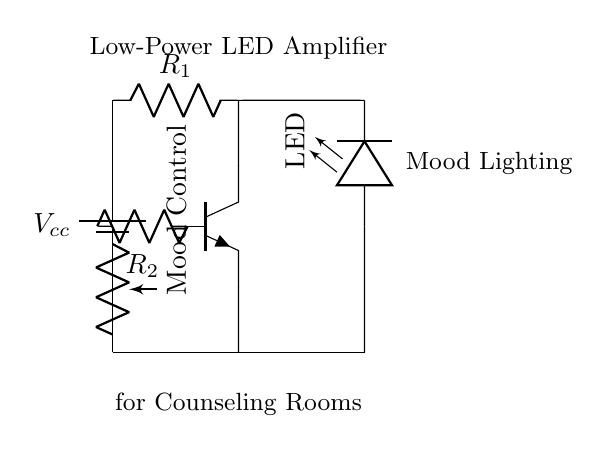What type of transistor is used in this circuit? The circuit diagram labels the transistor as npn, indicating it is an NPN type transistor. This can be confirmed by the specific labeling shown next to the drawn component.
Answer: NPN What is the purpose of the potentiometer in the circuit? The potentiometer, labeled as "Mood Control," adjusts the current flowing through the circuit, allowing the brightness of the LED to be changed for mood lighting. This function is essential in tailoring the lighting to fit different counseling environments.
Answer: Mood Control How many resistors are shown in the circuit? There are two resistors indicated in the circuit diagram, labeled as R1 and R2. This can be easily counted by identifying the resistor symbols within the circuit.
Answer: Two What component provides the power supply for the circuit? The power supply component in the circuit is labeled as Vcc, which signifies it is a battery that supplies voltage to the rest of the circuit. This is clearly marked at the beginning of the circuit.
Answer: Battery What does the LED represent in this configuration? The LED component in the circuit represents the light source used for mood lighting, indicated by the label next to the LED symbol. It visually demonstrates where the light emission occurs in the circuit.
Answer: Mood Lighting What is the role of the NPN transistor in this amplifier circuit? The NPN transistor functions as a switch or amplifier; it allows low current input from the base to control a larger current flowing from the collector to the emitter, effectively amplifying the light output from the LED. This understanding comes from the basic principles of how transistors operate within circuits.
Answer: Amplifier 